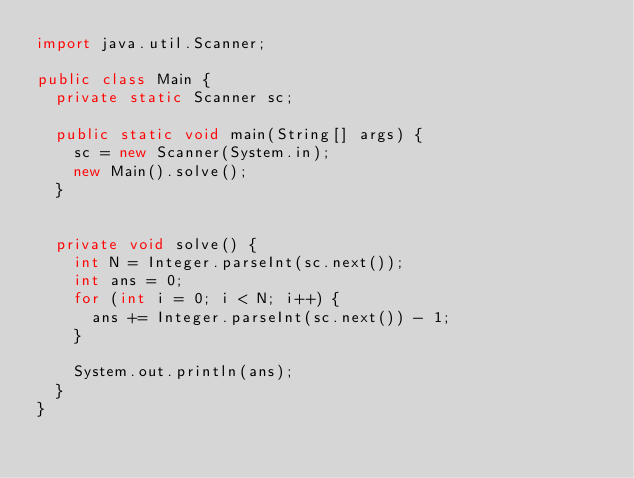Convert code to text. <code><loc_0><loc_0><loc_500><loc_500><_Java_>import java.util.Scanner;

public class Main {
  private static Scanner sc;

  public static void main(String[] args) {
    sc = new Scanner(System.in);
    new Main().solve();
  }


  private void solve() {
    int N = Integer.parseInt(sc.next());
    int ans = 0;
    for (int i = 0; i < N; i++) {
      ans += Integer.parseInt(sc.next()) - 1;
    }

    System.out.println(ans);
  }
}

</code> 